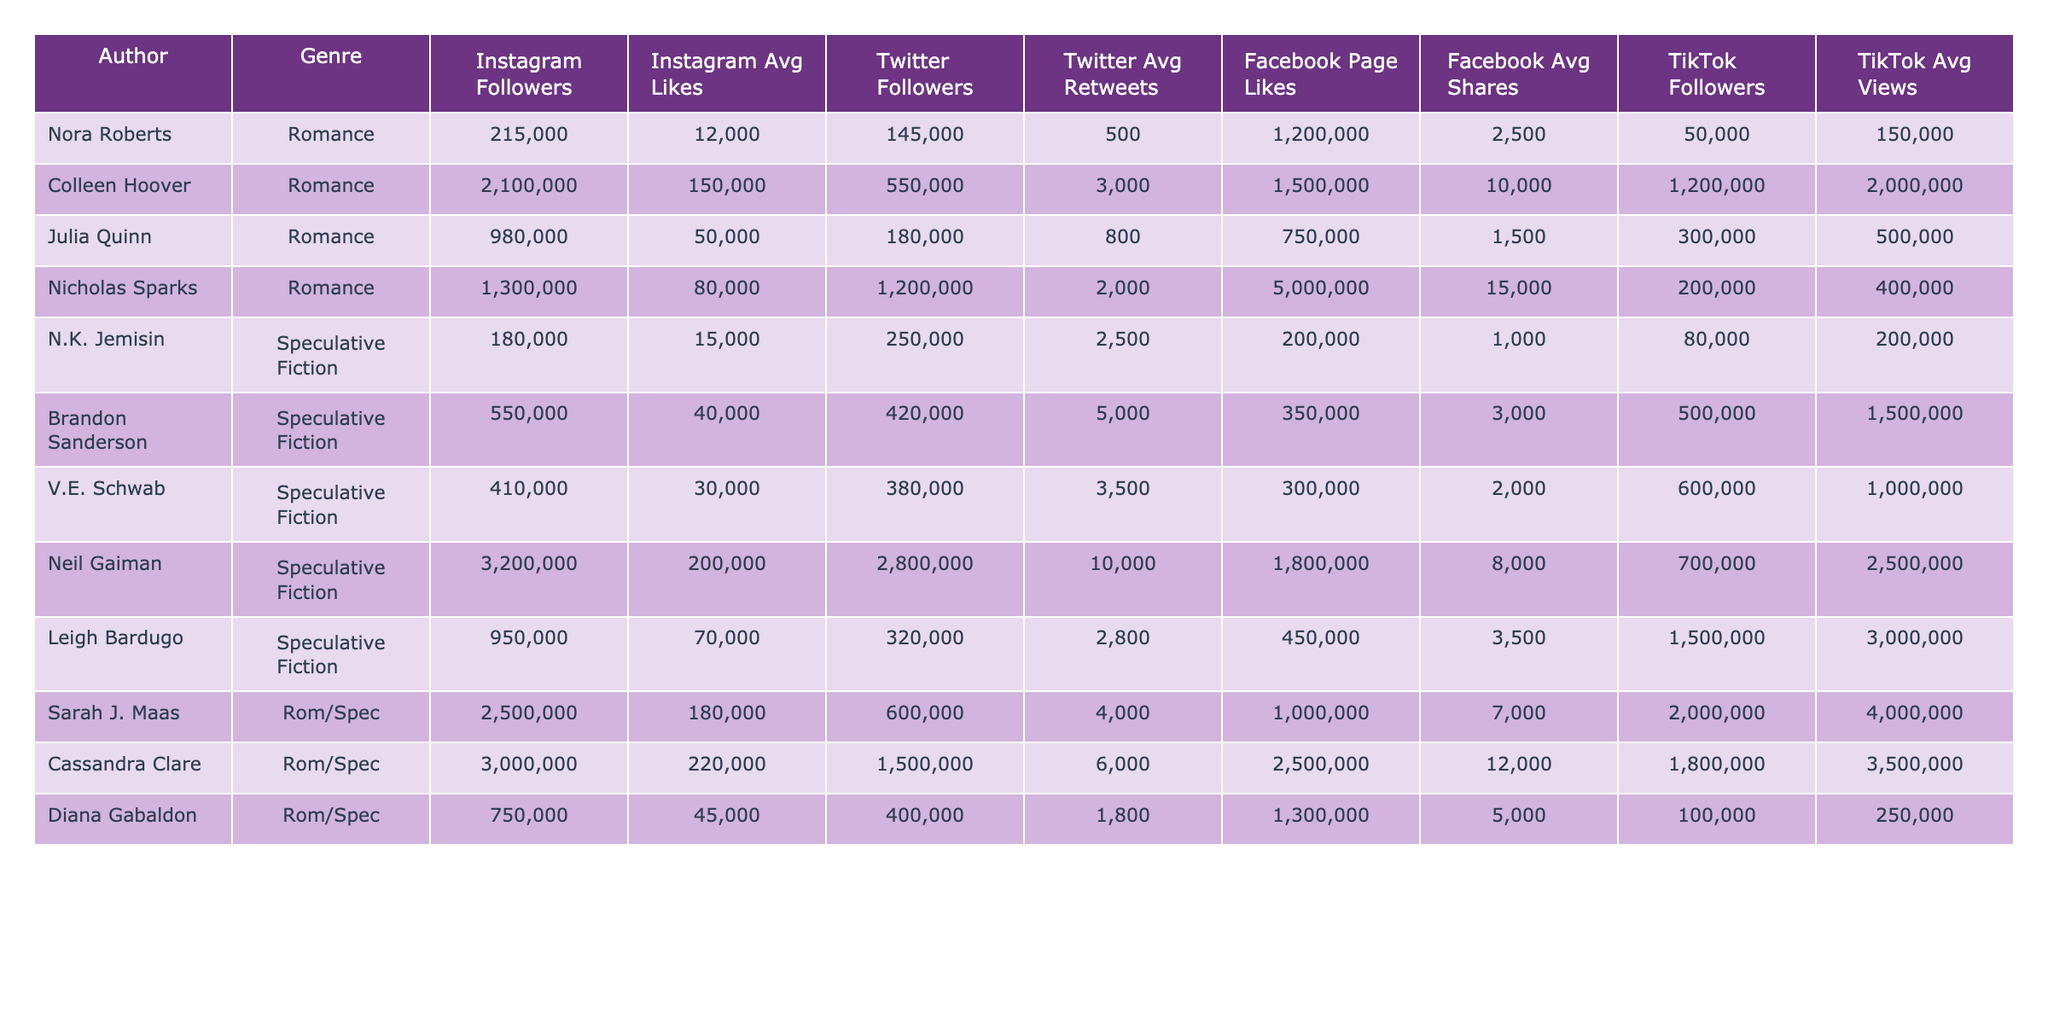What is the highest number of Instagram followers among the authors listed? By examining the Instagram Followers column, I see that Colleen Hoover has the highest number of followers with 2,100,000.
Answer: 2,100,000 Which author has the highest average likes on Instagram? Reviewing the Instagram Avg Likes column, Colleen Hoover also has the highest average likes at 150,000.
Answer: 150,000 How many Facebook Page Likes does Nicholas Sparks have? Looking at the Facebook Page Likes column, Nicholas Sparks has 5,000,000 likes on his Facebook page.
Answer: 5,000,000 What is the sum of TikTok Followers for all authors in the Romance genre? The authors in the Romance genre are Nora Roberts, Colleen Hoover, Julia Quinn, Nicholas Sparks, and Sarah J. Maas. Their TikTok followers are: 50,000 + 1,200,000 + 300,000 + 200,000 + 2,000,000 = 3,750,000.
Answer: 3,750,000 Do any authors have over 1 million TikTok Followers? Checking the TikTok Followers column, both Colleen Hoover and Sarah J. Maas have followers exceeding 1 million, confirming the statement to be true.
Answer: Yes What is the average number of Twitter Followers across all authors? The sum of Twitter Followers is calculated as: 145,000 + 550,000 + 180,000 + 1,200,000 + 250,000 + 420,000 + 380,000 + 2,800,000 + 1,500,000 + 400,000 = 7,475,000. Dividing by the number of authors (10) gives an average of about 747,500.
Answer: 747,500 Which genre has the highest average Facebook Page Likes? The average Facebook Page Likes for Romance authors is 1,250,000, and for Speculative Fiction authors, it is 1,075,000. Thus, Romance has the higher average.
Answer: Romance Is there an author with a specific average of 10,000 retweets on Twitter? By looking at the Twitter Avg Retweets column, the highest average is 10,000 for Neil Gaiman, confirming that he is the author associated with this statistic.
Answer: Yes What is the total average views for all TikTok followers from authors in the Romance genre? For the authors in the Romance genre, the values are 150,000 + 2,000,000 + 500,000 + 400,000 + 4,000,000 = 7,050,000. Dividing by 5 authors gives an average value of 1,410,000 views.
Answer: 1,410,000 How does the average Instagram followers of Romance authors compare with Speculative Fiction authors? The average for Romance authors is (2,100,000 + 215,000 + 980,000 + 1,300,000) / 4 = 1,398,750, while for Speculative Fiction authors, it is (180,000 + 550,000 + 410,000 + 3,200,000 + 950,000) / 5 = 868,000. Romance authors have a higher average Instagram following.
Answer: Romance authors have a higher average 